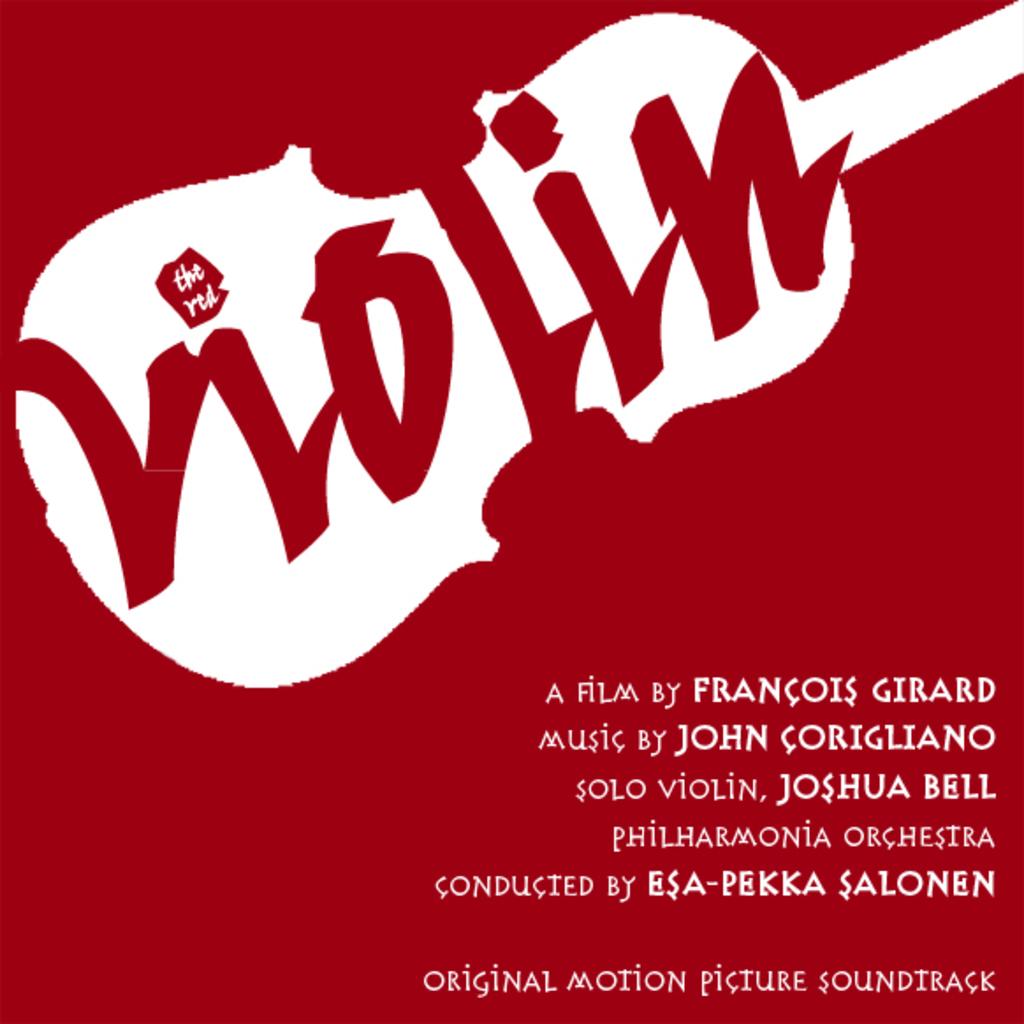Who did the music for this film?
Keep it short and to the point. John corigliano. 